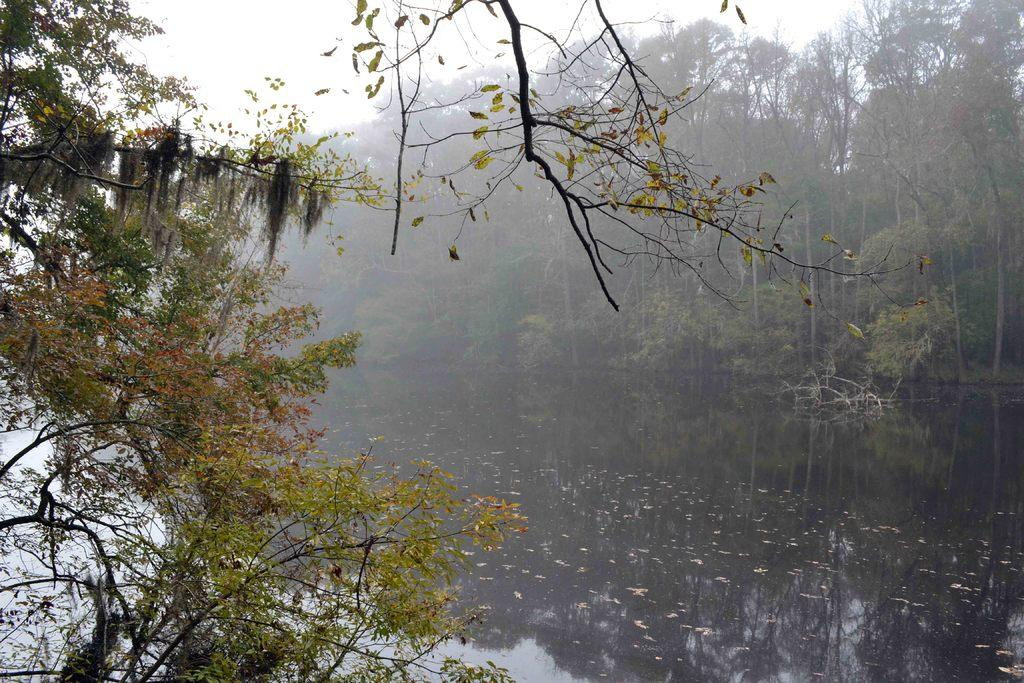What is present in the image that is not solid? There is water in the image. What type of vegetation can be seen in the image? There are trees in the image. Can you describe the reflection in the water? The reflection of trees is visible in the water. What is the value of the mark on the plane in the image? There is no plane present in the image, so it is not possible to determine the value of any mark on it. 